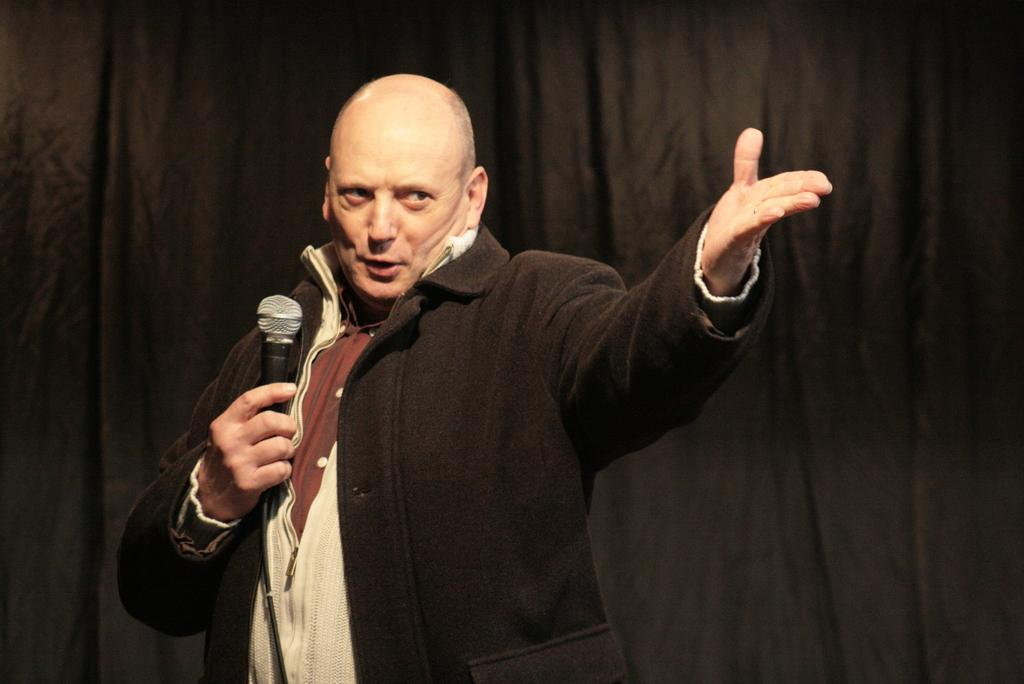Who is the main subject in the image? There is a man in the image. What is the man holding in his hand? The man is holding a microphone in his hand. What is the man doing in the image? The man is speaking and gesturing towards the audience with his hand. What can be seen behind the man in the image? There is a black screen behind the man. What time of day is it in the prison where the man is speaking? There is no prison present in the image, and the time of day cannot be determined from the image. 